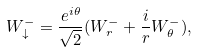Convert formula to latex. <formula><loc_0><loc_0><loc_500><loc_500>W _ { \downarrow } ^ { - } = \frac { e ^ { i \theta } } { \sqrt { 2 } } ( W _ { r } ^ { - } + \frac { i } { r } W _ { \theta } ^ { - } ) ,</formula> 